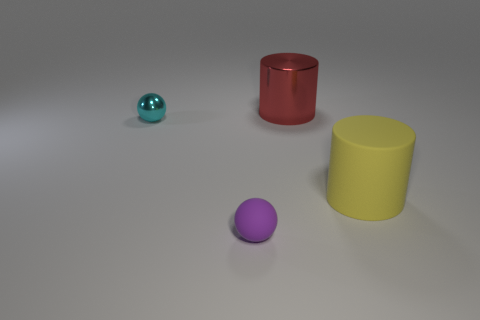Is the number of tiny balls that are behind the matte cylinder greater than the number of big red spheres?
Ensure brevity in your answer.  Yes. What material is the big red cylinder?
Ensure brevity in your answer.  Metal. There is another thing that is made of the same material as the tiny cyan thing; what is its shape?
Keep it short and to the point. Cylinder. There is a cylinder behind the matte thing that is behind the tiny matte ball; what is its size?
Keep it short and to the point. Large. What is the color of the cylinder in front of the big red metal object?
Give a very brief answer. Yellow. Is there a tiny cyan object that has the same shape as the small purple matte thing?
Keep it short and to the point. Yes. Is the number of big yellow matte cylinders that are to the left of the tiny shiny thing less than the number of small purple balls that are right of the yellow cylinder?
Your response must be concise. No. The matte cylinder is what color?
Offer a very short reply. Yellow. Is there a large cylinder that is behind the metal object that is in front of the red cylinder?
Your response must be concise. Yes. What number of spheres have the same size as the red metal cylinder?
Provide a succinct answer. 0. 